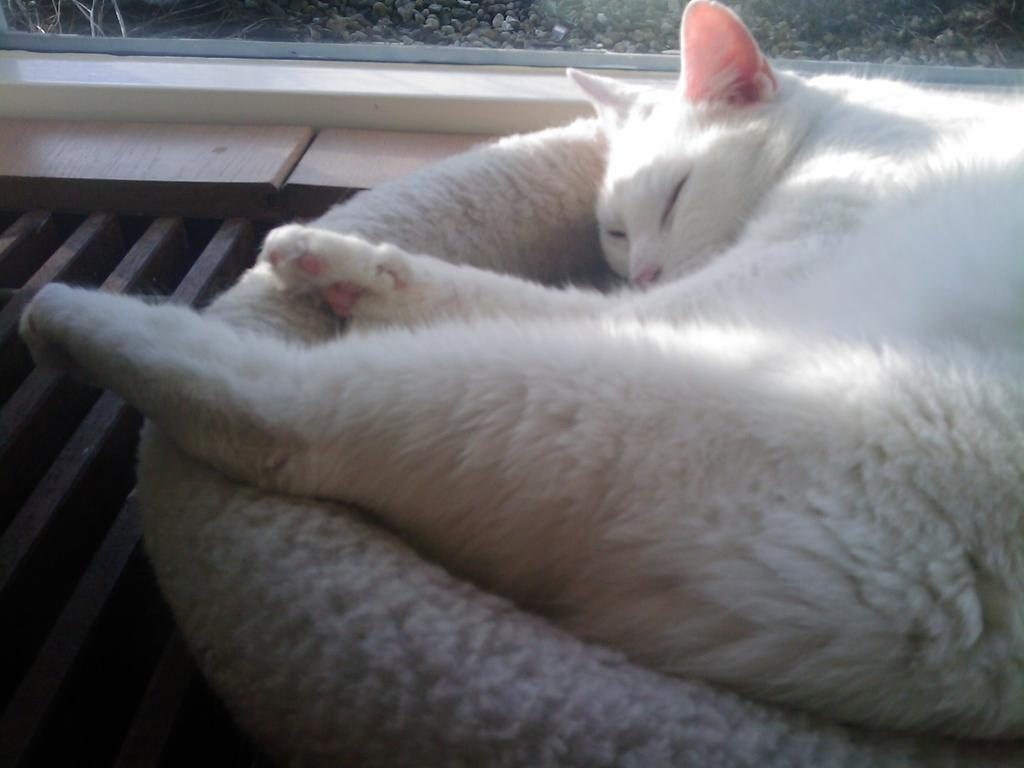What type of animal is in the image? There is a cat in the image. What is the cat doing in the image? The cat is sleeping on a bed. What can be seen through the window in the image? Stones are visible through the window. What type of duck can be seen bursting through the window in the image? There is no duck present in the image, nor is there any indication of a duck bursting through the window. 